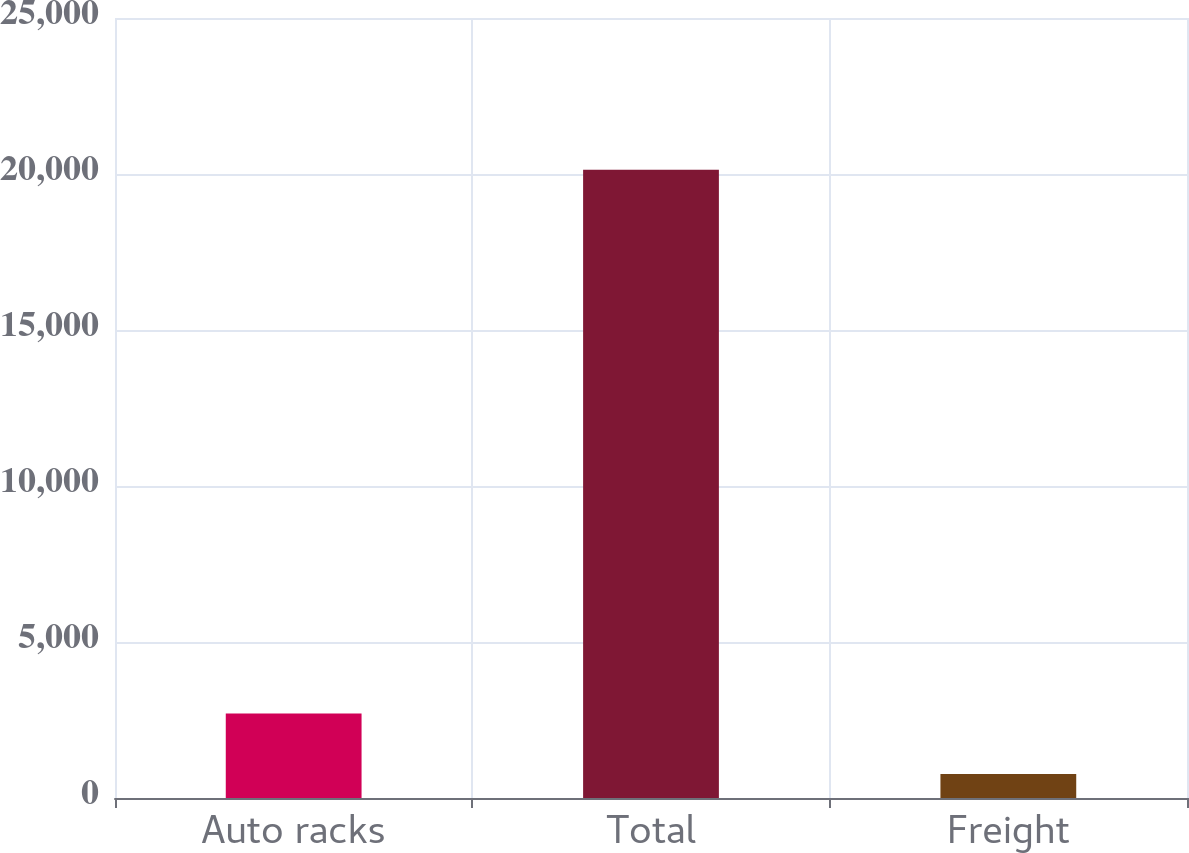<chart> <loc_0><loc_0><loc_500><loc_500><bar_chart><fcel>Auto racks<fcel>Total<fcel>Freight<nl><fcel>2709.7<fcel>20140<fcel>773<nl></chart> 